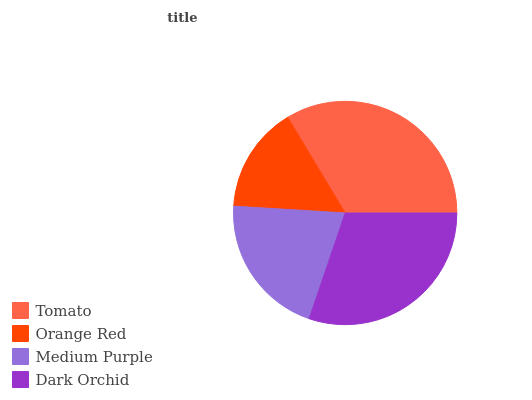Is Orange Red the minimum?
Answer yes or no. Yes. Is Tomato the maximum?
Answer yes or no. Yes. Is Medium Purple the minimum?
Answer yes or no. No. Is Medium Purple the maximum?
Answer yes or no. No. Is Medium Purple greater than Orange Red?
Answer yes or no. Yes. Is Orange Red less than Medium Purple?
Answer yes or no. Yes. Is Orange Red greater than Medium Purple?
Answer yes or no. No. Is Medium Purple less than Orange Red?
Answer yes or no. No. Is Dark Orchid the high median?
Answer yes or no. Yes. Is Medium Purple the low median?
Answer yes or no. Yes. Is Tomato the high median?
Answer yes or no. No. Is Tomato the low median?
Answer yes or no. No. 